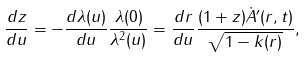Convert formula to latex. <formula><loc_0><loc_0><loc_500><loc_500>\frac { d z } { d u } = - \frac { d \lambda ( u ) } { d u } \frac { \lambda ( 0 ) } { \lambda ^ { 2 } ( u ) } = \frac { d r } { d u } \frac { ( 1 + z ) \dot { A } ^ { \prime } ( r , t ) } { \sqrt { 1 - k ( r ) } } ,</formula> 